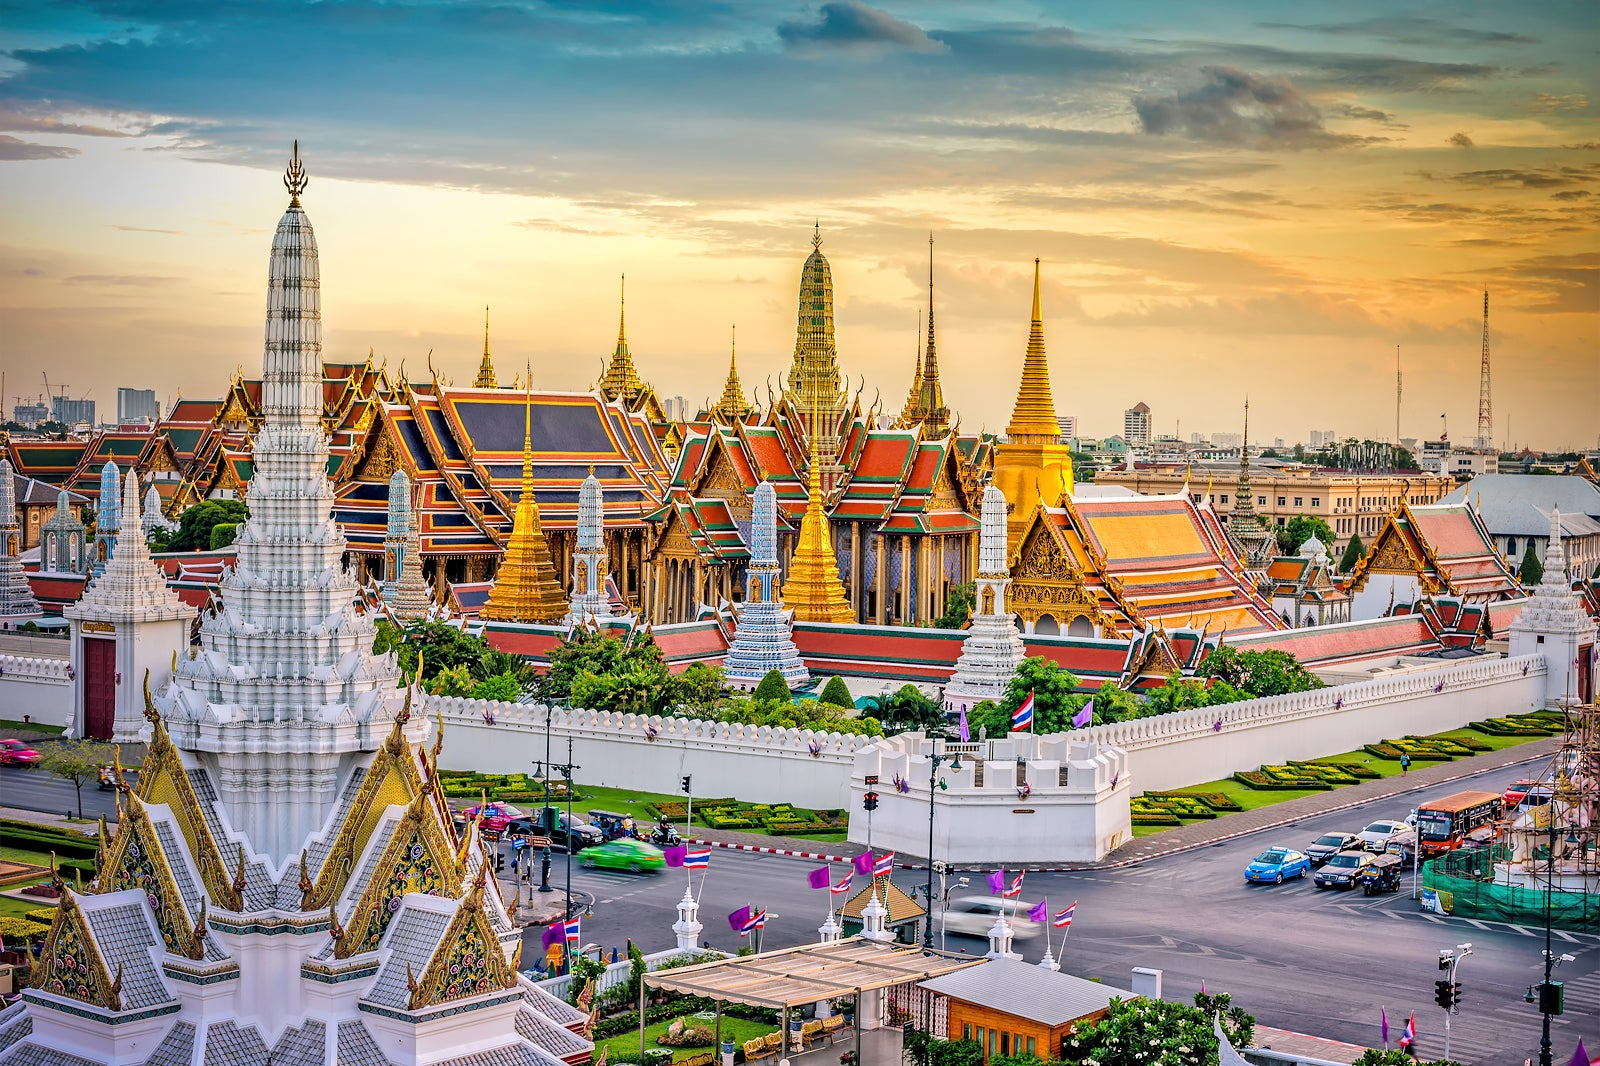If you could time travel, which period would you choose to witness at the Grand Palace? If I could time travel, I would choose to witness the coronation of King Rama V in 1868. This event marked a significant turning point in Thai history as King Rama V was known for his progressive reforms and modernization efforts. The grandeur and ceremonial splendor of the coronation would highlight the palace’s cultural and historical significance. Witnessing this momentous occasion would provide a unique glimpse into the rich traditions and royal customs of the time. 